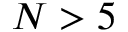Convert formula to latex. <formula><loc_0><loc_0><loc_500><loc_500>N > 5</formula> 